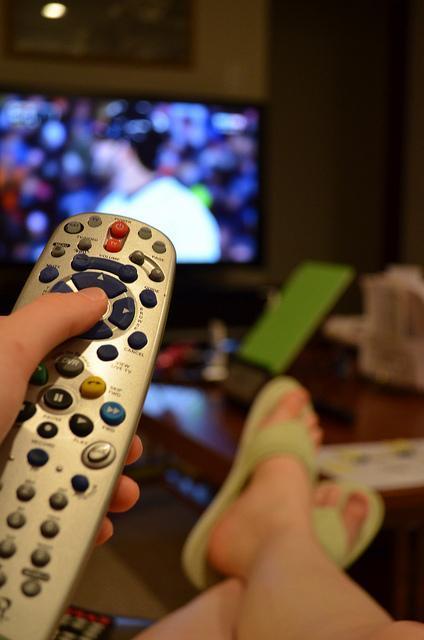How many people are there?
Give a very brief answer. 2. 